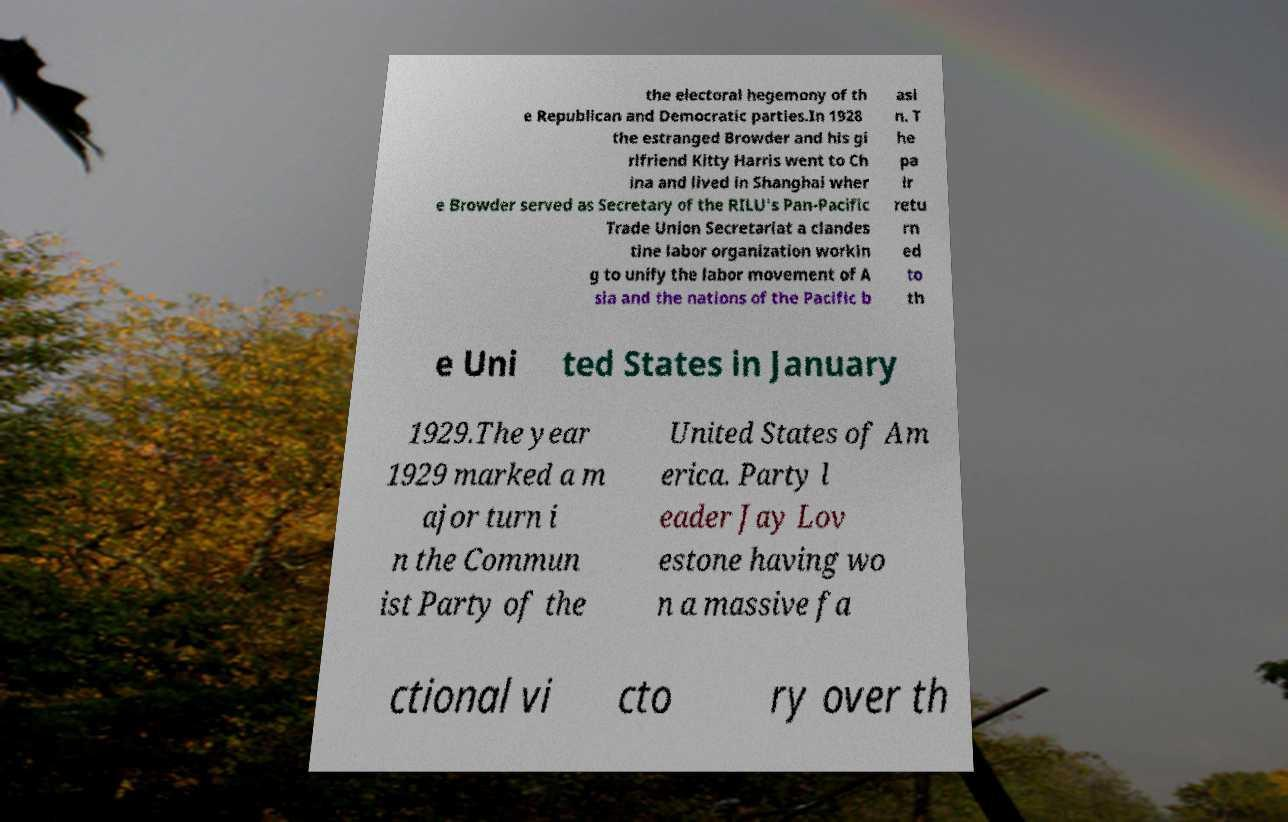I need the written content from this picture converted into text. Can you do that? the electoral hegemony of th e Republican and Democratic parties.In 1928 the estranged Browder and his gi rlfriend Kitty Harris went to Ch ina and lived in Shanghai wher e Browder served as Secretary of the RILU's Pan-Pacific Trade Union Secretariat a clandes tine labor organization workin g to unify the labor movement of A sia and the nations of the Pacific b asi n. T he pa ir retu rn ed to th e Uni ted States in January 1929.The year 1929 marked a m ajor turn i n the Commun ist Party of the United States of Am erica. Party l eader Jay Lov estone having wo n a massive fa ctional vi cto ry over th 